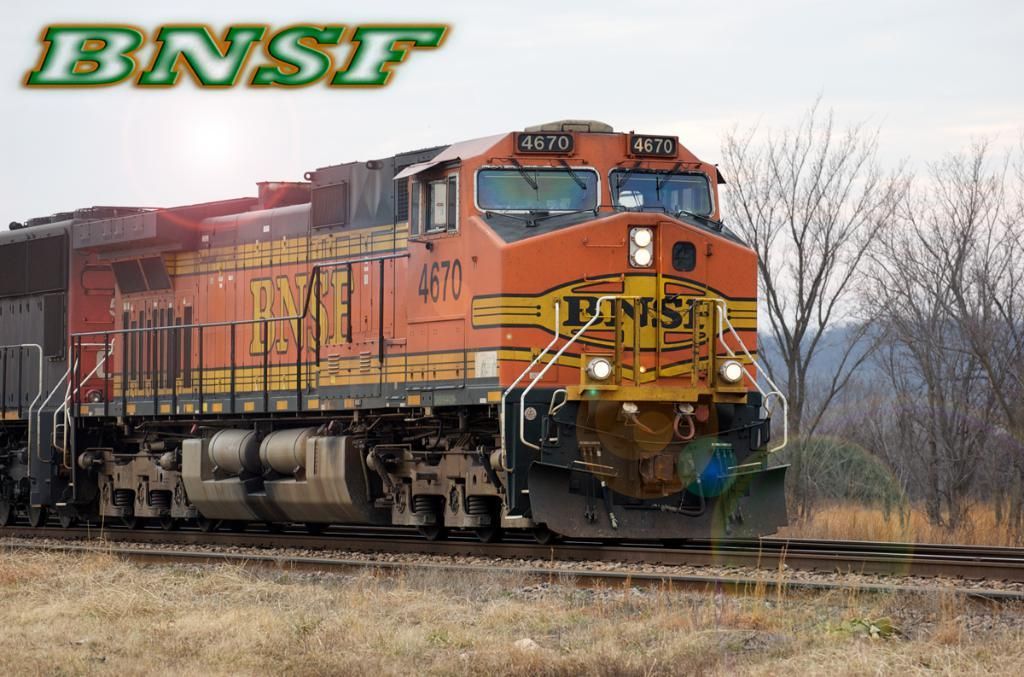What is the main subject of the image? There is a train in the image. Where is the train located? The train is on a railway track. What can be seen in the background of the image? There are trees visible in the image. What is the ground covered with in the image? There is grass on the ground in the image. What is present in the top left corner of the image? There is text in the top left corner of the image. How would you describe the weather in the image? The sky is cloudy in the image. How many dogs are playing with the train in the image? There are no dogs present in the image, and the train is not being played with. 